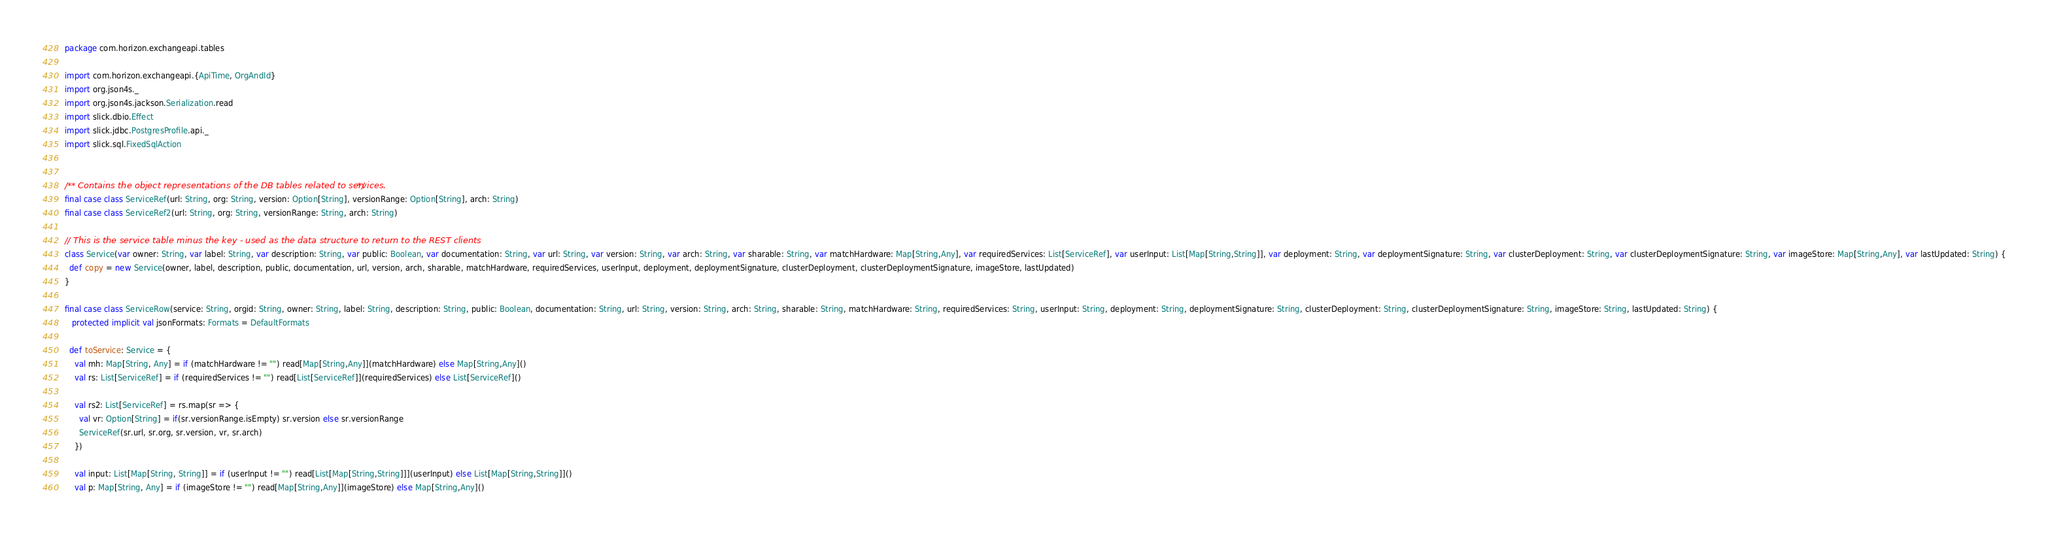Convert code to text. <code><loc_0><loc_0><loc_500><loc_500><_Scala_>package com.horizon.exchangeapi.tables

import com.horizon.exchangeapi.{ApiTime, OrgAndId}
import org.json4s._
import org.json4s.jackson.Serialization.read
import slick.dbio.Effect
import slick.jdbc.PostgresProfile.api._
import slick.sql.FixedSqlAction


/** Contains the object representations of the DB tables related to services. */
final case class ServiceRef(url: String, org: String, version: Option[String], versionRange: Option[String], arch: String)
final case class ServiceRef2(url: String, org: String, versionRange: String, arch: String)

// This is the service table minus the key - used as the data structure to return to the REST clients
class Service(var owner: String, var label: String, var description: String, var public: Boolean, var documentation: String, var url: String, var version: String, var arch: String, var sharable: String, var matchHardware: Map[String,Any], var requiredServices: List[ServiceRef], var userInput: List[Map[String,String]], var deployment: String, var deploymentSignature: String, var clusterDeployment: String, var clusterDeploymentSignature: String, var imageStore: Map[String,Any], var lastUpdated: String) {
  def copy = new Service(owner, label, description, public, documentation, url, version, arch, sharable, matchHardware, requiredServices, userInput, deployment, deploymentSignature, clusterDeployment, clusterDeploymentSignature, imageStore, lastUpdated)
}

final case class ServiceRow(service: String, orgid: String, owner: String, label: String, description: String, public: Boolean, documentation: String, url: String, version: String, arch: String, sharable: String, matchHardware: String, requiredServices: String, userInput: String, deployment: String, deploymentSignature: String, clusterDeployment: String, clusterDeploymentSignature: String, imageStore: String, lastUpdated: String) {
   protected implicit val jsonFormats: Formats = DefaultFormats

  def toService: Service = {
    val mh: Map[String, Any] = if (matchHardware != "") read[Map[String,Any]](matchHardware) else Map[String,Any]()
    val rs: List[ServiceRef] = if (requiredServices != "") read[List[ServiceRef]](requiredServices) else List[ServiceRef]()

    val rs2: List[ServiceRef] = rs.map(sr => {
      val vr: Option[String] = if(sr.versionRange.isEmpty) sr.version else sr.versionRange
      ServiceRef(sr.url, sr.org, sr.version, vr, sr.arch)
    })

    val input: List[Map[String, String]] = if (userInput != "") read[List[Map[String,String]]](userInput) else List[Map[String,String]]()
    val p: Map[String, Any] = if (imageStore != "") read[Map[String,Any]](imageStore) else Map[String,Any]()</code> 